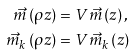Convert formula to latex. <formula><loc_0><loc_0><loc_500><loc_500>\vec { m } \left ( \rho z \right ) & = V \vec { m } \left ( z \right ) , \\ \vec { m } _ { k } \left ( \rho z \right ) & = V \vec { m } _ { k } \left ( z \right )</formula> 